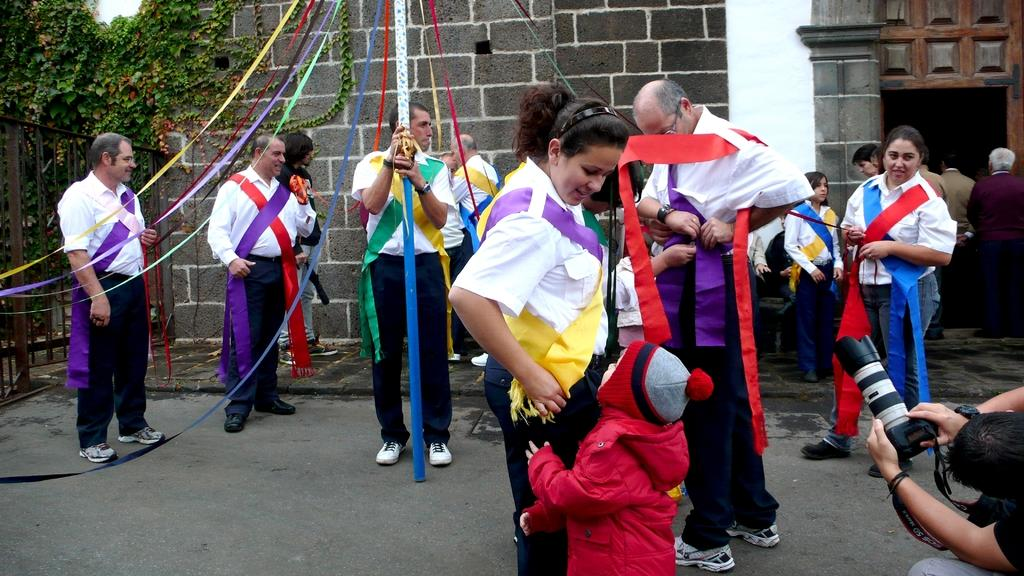How many people are in the image? There are people in the image, but the exact number is not specified. What is one person doing in the image? One person is holding a camera. What type of structure can be seen in the image? There is a wall visible in the image. What is the purpose of the gate in the image? The gate in the image may serve as an entrance or exit to a property or area. What type of vegetation is present in the image? There are plants in the image. What type of jelly can be seen on the wall in the image? There is no jelly present on the wall in the image. How many twigs are visible in the image? The facts do not mention any twigs, so we cannot determine the number of twigs in the image. 